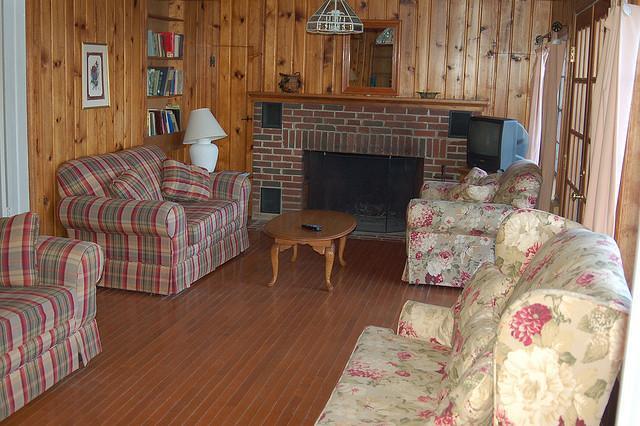How many lamps are in the room?
Give a very brief answer. 1. How many chairs are there?
Give a very brief answer. 2. How many couches can you see?
Give a very brief answer. 3. 